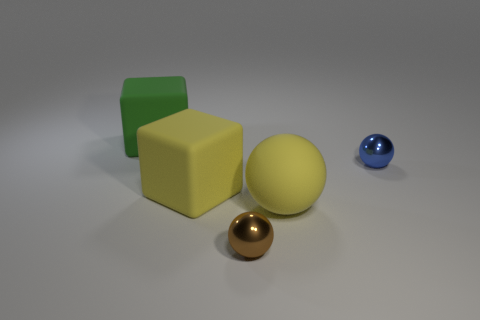How many other objects are the same color as the big sphere?
Make the answer very short. 1. There is a big yellow matte thing that is to the right of the small brown sphere; what is its shape?
Offer a very short reply. Sphere. How many objects are either tiny purple shiny blocks or yellow matte cubes?
Provide a succinct answer. 1. There is a blue ball; is its size the same as the yellow matte object behind the yellow rubber sphere?
Your response must be concise. No. How many other objects are the same material as the large sphere?
Give a very brief answer. 2. How many objects are either large blocks that are in front of the large green matte cube or large objects behind the rubber sphere?
Give a very brief answer. 2. What material is the other object that is the same shape as the green rubber thing?
Your answer should be very brief. Rubber. Are there any yellow matte spheres?
Offer a terse response. Yes. There is a object that is behind the yellow rubber cube and left of the large yellow ball; what size is it?
Make the answer very short. Large. What is the shape of the tiny blue metal thing?
Keep it short and to the point. Sphere. 